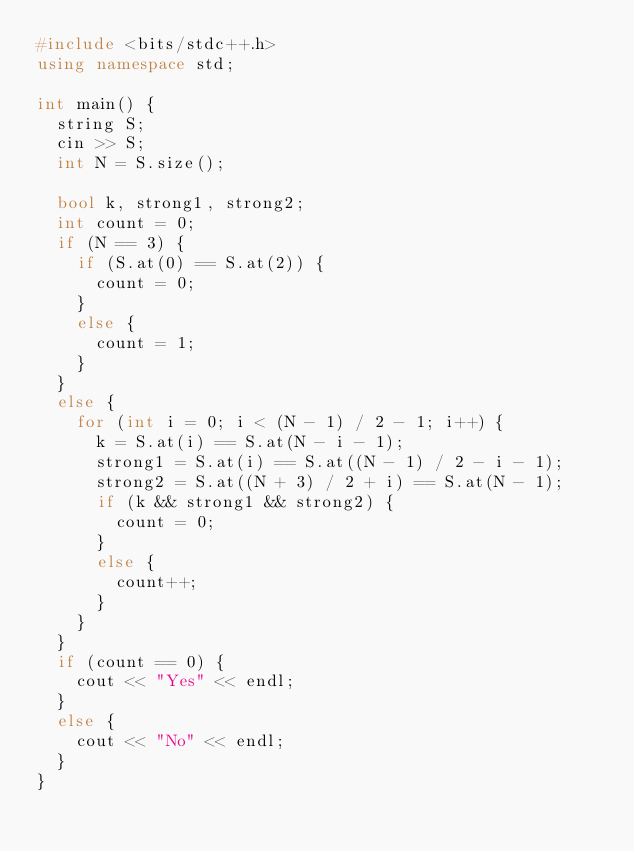Convert code to text. <code><loc_0><loc_0><loc_500><loc_500><_C++_>#include <bits/stdc++.h>
using namespace std;

int main() {
  string S;
  cin >> S;
  int N = S.size();
  
  bool k, strong1, strong2;
  int count = 0;
  if (N == 3) {
    if (S.at(0) == S.at(2)) {
      count = 0;
    }
    else {
      count = 1;
    }
  }
  else {
    for (int i = 0; i < (N - 1) / 2 - 1; i++) {
      k = S.at(i) == S.at(N - i - 1);
      strong1 = S.at(i) == S.at((N - 1) / 2 - i - 1);
      strong2 = S.at((N + 3) / 2 + i) == S.at(N - 1);
      if (k && strong1 && strong2) {
        count = 0;
      }
      else {
        count++;
      }
    }
  }
  if (count == 0) {
    cout << "Yes" << endl;
  }
  else {
    cout << "No" << endl;
  }  
}</code> 